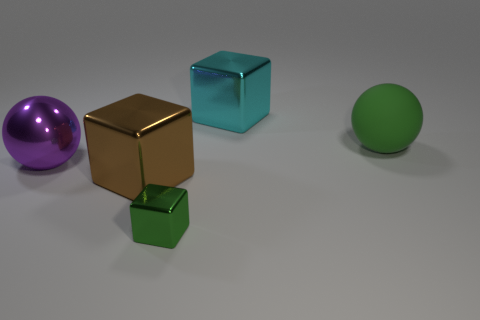Subtract all green spheres. Subtract all cyan blocks. How many spheres are left? 1 Add 1 blocks. How many objects exist? 6 Subtract all blocks. How many objects are left? 2 Subtract all shiny objects. Subtract all brown metallic cubes. How many objects are left? 0 Add 3 metallic spheres. How many metallic spheres are left? 4 Add 2 yellow metallic balls. How many yellow metallic balls exist? 2 Subtract 0 yellow cubes. How many objects are left? 5 